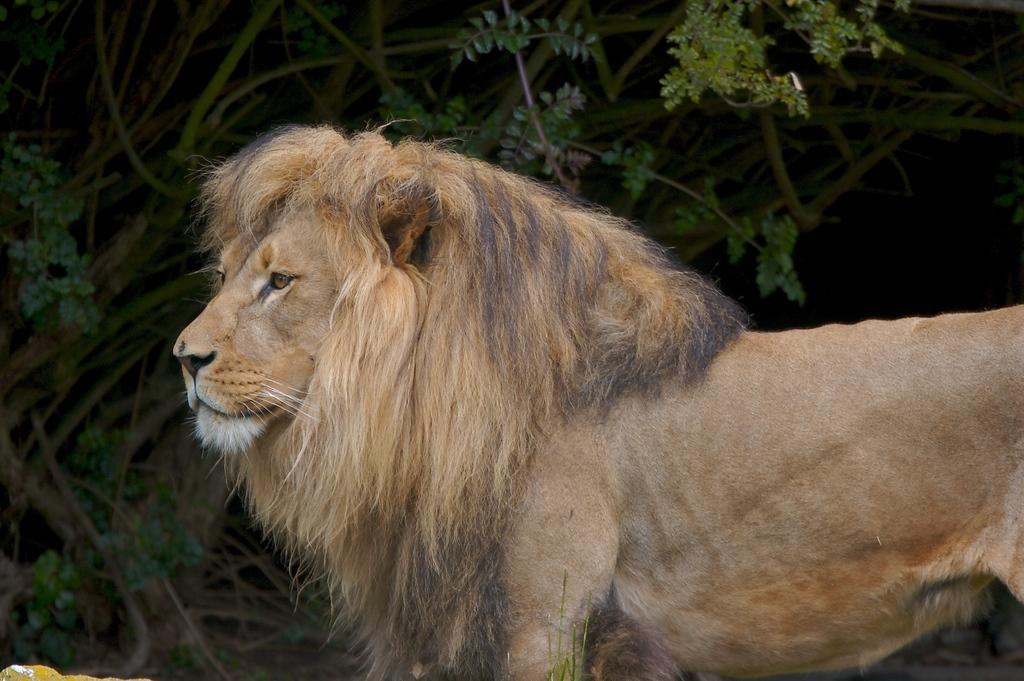What animal is the main subject of the image? There is a lion in the image. In which direction is the lion facing? The lion is facing towards the left side. What can be seen in the background of the image? There are plants in the background of the image. How many hearts can be seen beating in the image? There are no hearts visible in the image, as it features a lion and plants in the background. 